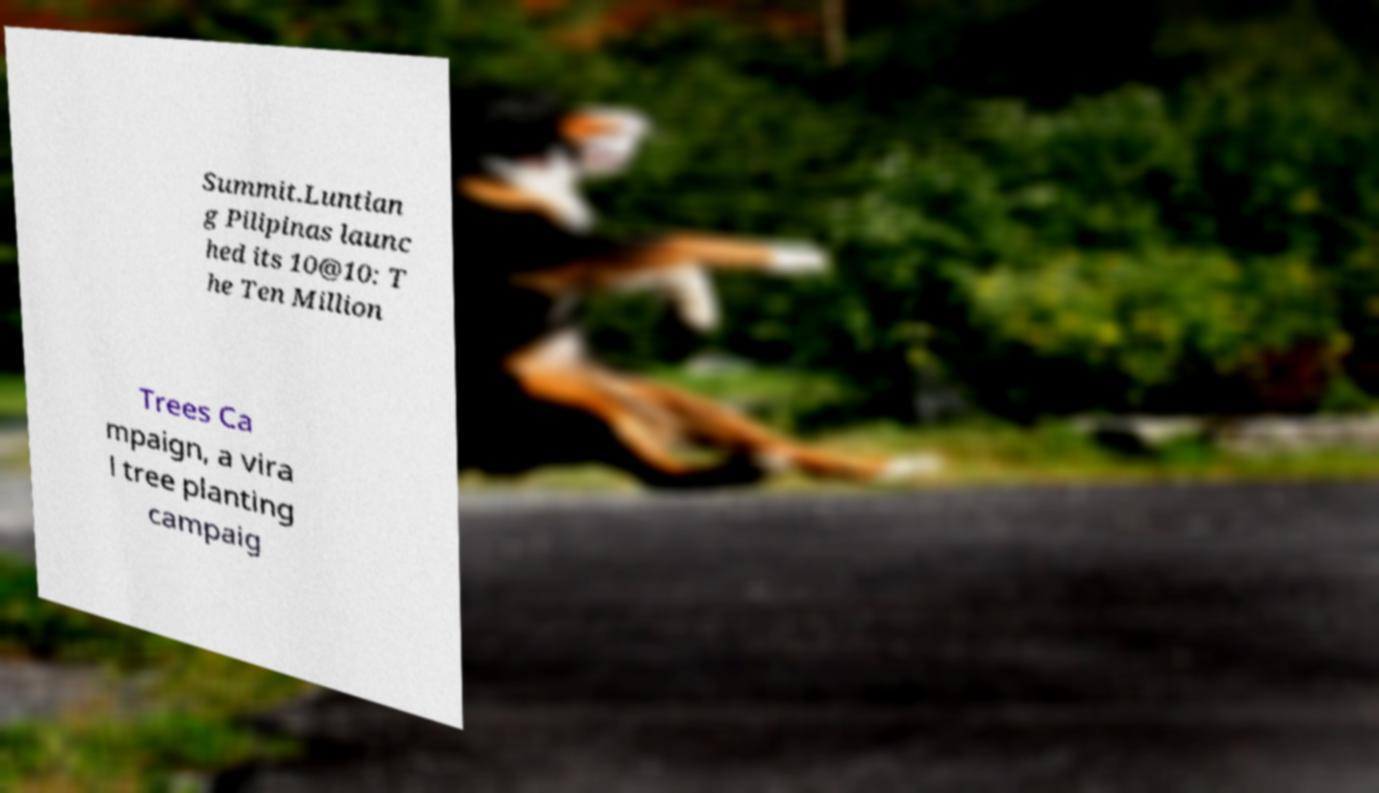Could you extract and type out the text from this image? Summit.Luntian g Pilipinas launc hed its 10@10: T he Ten Million Trees Ca mpaign, a vira l tree planting campaig 